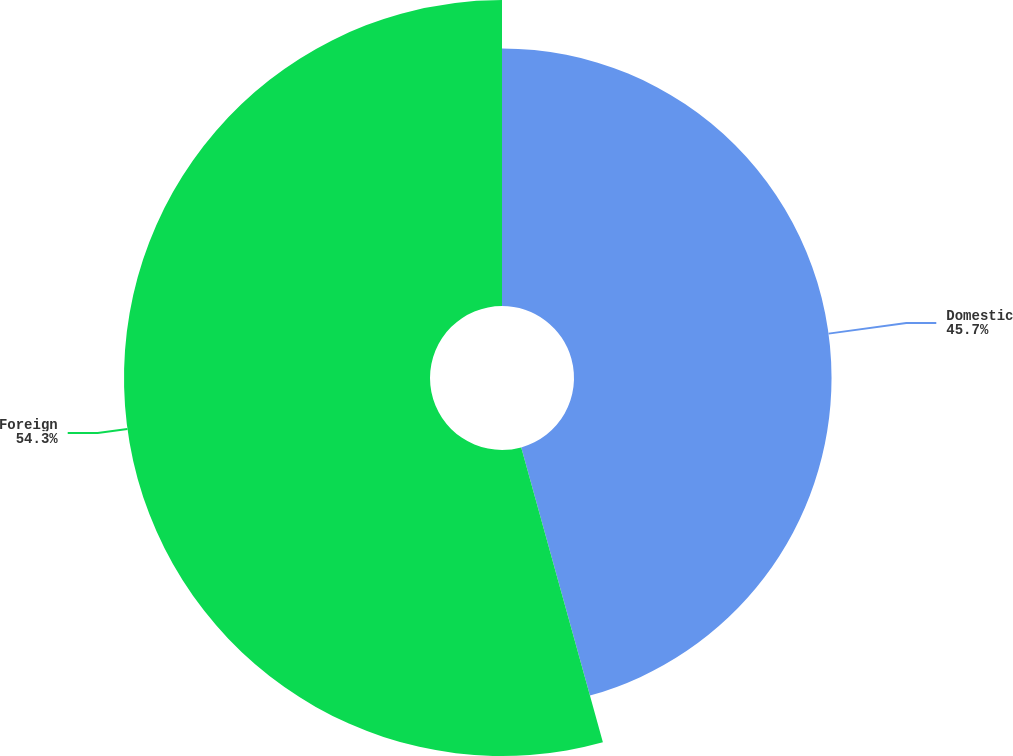<chart> <loc_0><loc_0><loc_500><loc_500><pie_chart><fcel>Domestic<fcel>Foreign<nl><fcel>45.7%<fcel>54.3%<nl></chart> 